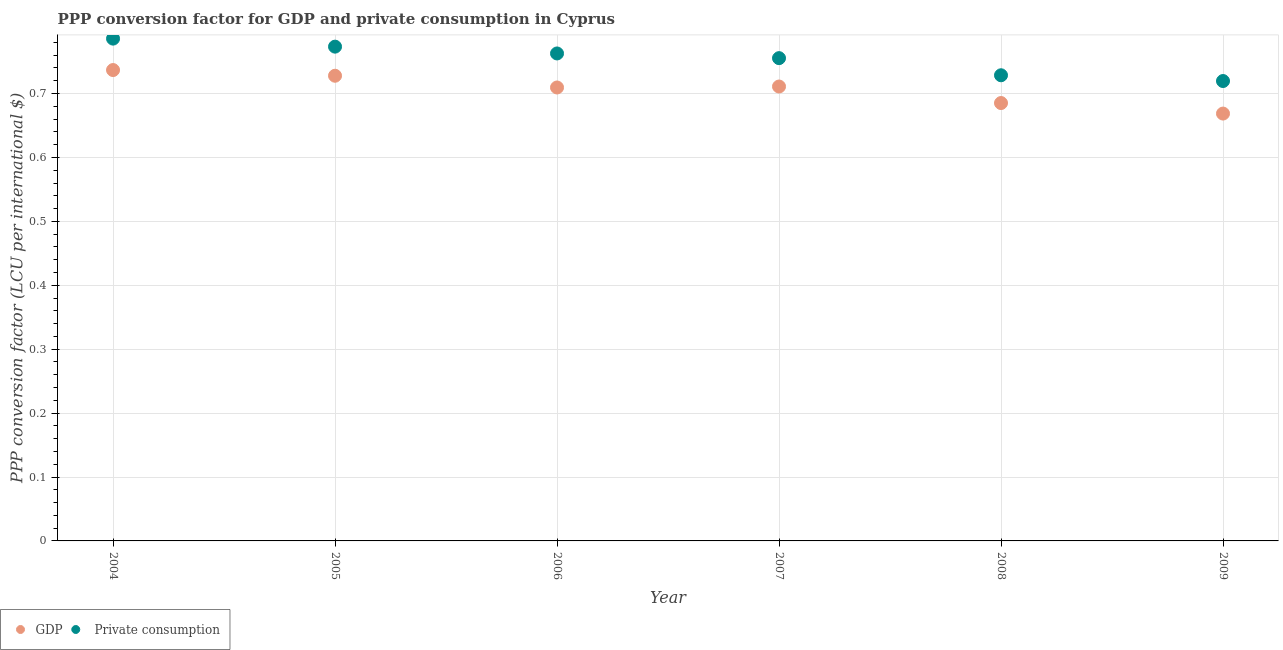How many different coloured dotlines are there?
Your response must be concise. 2. Is the number of dotlines equal to the number of legend labels?
Offer a very short reply. Yes. What is the ppp conversion factor for private consumption in 2007?
Your answer should be very brief. 0.76. Across all years, what is the maximum ppp conversion factor for gdp?
Keep it short and to the point. 0.74. Across all years, what is the minimum ppp conversion factor for private consumption?
Provide a succinct answer. 0.72. In which year was the ppp conversion factor for gdp maximum?
Provide a succinct answer. 2004. In which year was the ppp conversion factor for gdp minimum?
Ensure brevity in your answer.  2009. What is the total ppp conversion factor for gdp in the graph?
Offer a terse response. 4.24. What is the difference between the ppp conversion factor for gdp in 2004 and that in 2006?
Ensure brevity in your answer.  0.03. What is the difference between the ppp conversion factor for private consumption in 2009 and the ppp conversion factor for gdp in 2004?
Keep it short and to the point. -0.02. What is the average ppp conversion factor for gdp per year?
Your answer should be compact. 0.71. In the year 2005, what is the difference between the ppp conversion factor for gdp and ppp conversion factor for private consumption?
Your answer should be very brief. -0.05. In how many years, is the ppp conversion factor for gdp greater than 0.02 LCU?
Provide a short and direct response. 6. What is the ratio of the ppp conversion factor for gdp in 2005 to that in 2006?
Give a very brief answer. 1.03. Is the ppp conversion factor for private consumption in 2005 less than that in 2008?
Keep it short and to the point. No. Is the difference between the ppp conversion factor for private consumption in 2006 and 2007 greater than the difference between the ppp conversion factor for gdp in 2006 and 2007?
Your answer should be very brief. Yes. What is the difference between the highest and the second highest ppp conversion factor for private consumption?
Ensure brevity in your answer.  0.01. What is the difference between the highest and the lowest ppp conversion factor for gdp?
Your answer should be very brief. 0.07. Is the ppp conversion factor for gdp strictly greater than the ppp conversion factor for private consumption over the years?
Your answer should be very brief. No. Is the ppp conversion factor for gdp strictly less than the ppp conversion factor for private consumption over the years?
Provide a succinct answer. Yes. What is the difference between two consecutive major ticks on the Y-axis?
Offer a terse response. 0.1. Does the graph contain any zero values?
Your answer should be very brief. No. How are the legend labels stacked?
Give a very brief answer. Horizontal. What is the title of the graph?
Offer a very short reply. PPP conversion factor for GDP and private consumption in Cyprus. Does "Female entrants" appear as one of the legend labels in the graph?
Ensure brevity in your answer.  No. What is the label or title of the X-axis?
Make the answer very short. Year. What is the label or title of the Y-axis?
Give a very brief answer. PPP conversion factor (LCU per international $). What is the PPP conversion factor (LCU per international $) of GDP in 2004?
Provide a short and direct response. 0.74. What is the PPP conversion factor (LCU per international $) in  Private consumption in 2004?
Provide a succinct answer. 0.79. What is the PPP conversion factor (LCU per international $) of GDP in 2005?
Provide a short and direct response. 0.73. What is the PPP conversion factor (LCU per international $) in  Private consumption in 2005?
Offer a very short reply. 0.77. What is the PPP conversion factor (LCU per international $) of GDP in 2006?
Provide a short and direct response. 0.71. What is the PPP conversion factor (LCU per international $) in  Private consumption in 2006?
Your answer should be very brief. 0.76. What is the PPP conversion factor (LCU per international $) in GDP in 2007?
Provide a succinct answer. 0.71. What is the PPP conversion factor (LCU per international $) of  Private consumption in 2007?
Offer a terse response. 0.76. What is the PPP conversion factor (LCU per international $) of GDP in 2008?
Give a very brief answer. 0.69. What is the PPP conversion factor (LCU per international $) in  Private consumption in 2008?
Your response must be concise. 0.73. What is the PPP conversion factor (LCU per international $) of GDP in 2009?
Make the answer very short. 0.67. What is the PPP conversion factor (LCU per international $) of  Private consumption in 2009?
Give a very brief answer. 0.72. Across all years, what is the maximum PPP conversion factor (LCU per international $) of GDP?
Make the answer very short. 0.74. Across all years, what is the maximum PPP conversion factor (LCU per international $) of  Private consumption?
Ensure brevity in your answer.  0.79. Across all years, what is the minimum PPP conversion factor (LCU per international $) of GDP?
Your response must be concise. 0.67. Across all years, what is the minimum PPP conversion factor (LCU per international $) in  Private consumption?
Your response must be concise. 0.72. What is the total PPP conversion factor (LCU per international $) of GDP in the graph?
Keep it short and to the point. 4.24. What is the total PPP conversion factor (LCU per international $) of  Private consumption in the graph?
Offer a very short reply. 4.53. What is the difference between the PPP conversion factor (LCU per international $) of GDP in 2004 and that in 2005?
Make the answer very short. 0.01. What is the difference between the PPP conversion factor (LCU per international $) in  Private consumption in 2004 and that in 2005?
Keep it short and to the point. 0.01. What is the difference between the PPP conversion factor (LCU per international $) of GDP in 2004 and that in 2006?
Your response must be concise. 0.03. What is the difference between the PPP conversion factor (LCU per international $) in  Private consumption in 2004 and that in 2006?
Give a very brief answer. 0.02. What is the difference between the PPP conversion factor (LCU per international $) in GDP in 2004 and that in 2007?
Ensure brevity in your answer.  0.03. What is the difference between the PPP conversion factor (LCU per international $) in  Private consumption in 2004 and that in 2007?
Ensure brevity in your answer.  0.03. What is the difference between the PPP conversion factor (LCU per international $) in GDP in 2004 and that in 2008?
Your answer should be compact. 0.05. What is the difference between the PPP conversion factor (LCU per international $) of  Private consumption in 2004 and that in 2008?
Offer a terse response. 0.06. What is the difference between the PPP conversion factor (LCU per international $) of GDP in 2004 and that in 2009?
Keep it short and to the point. 0.07. What is the difference between the PPP conversion factor (LCU per international $) of  Private consumption in 2004 and that in 2009?
Provide a short and direct response. 0.07. What is the difference between the PPP conversion factor (LCU per international $) of GDP in 2005 and that in 2006?
Offer a terse response. 0.02. What is the difference between the PPP conversion factor (LCU per international $) of  Private consumption in 2005 and that in 2006?
Your response must be concise. 0.01. What is the difference between the PPP conversion factor (LCU per international $) in GDP in 2005 and that in 2007?
Ensure brevity in your answer.  0.02. What is the difference between the PPP conversion factor (LCU per international $) in  Private consumption in 2005 and that in 2007?
Give a very brief answer. 0.02. What is the difference between the PPP conversion factor (LCU per international $) in GDP in 2005 and that in 2008?
Your answer should be compact. 0.04. What is the difference between the PPP conversion factor (LCU per international $) of  Private consumption in 2005 and that in 2008?
Ensure brevity in your answer.  0.04. What is the difference between the PPP conversion factor (LCU per international $) of GDP in 2005 and that in 2009?
Give a very brief answer. 0.06. What is the difference between the PPP conversion factor (LCU per international $) of  Private consumption in 2005 and that in 2009?
Give a very brief answer. 0.05. What is the difference between the PPP conversion factor (LCU per international $) of GDP in 2006 and that in 2007?
Provide a short and direct response. -0. What is the difference between the PPP conversion factor (LCU per international $) in  Private consumption in 2006 and that in 2007?
Give a very brief answer. 0.01. What is the difference between the PPP conversion factor (LCU per international $) of GDP in 2006 and that in 2008?
Offer a terse response. 0.02. What is the difference between the PPP conversion factor (LCU per international $) in  Private consumption in 2006 and that in 2008?
Provide a succinct answer. 0.03. What is the difference between the PPP conversion factor (LCU per international $) in GDP in 2006 and that in 2009?
Your answer should be very brief. 0.04. What is the difference between the PPP conversion factor (LCU per international $) of  Private consumption in 2006 and that in 2009?
Provide a succinct answer. 0.04. What is the difference between the PPP conversion factor (LCU per international $) of GDP in 2007 and that in 2008?
Offer a terse response. 0.03. What is the difference between the PPP conversion factor (LCU per international $) in  Private consumption in 2007 and that in 2008?
Provide a succinct answer. 0.03. What is the difference between the PPP conversion factor (LCU per international $) of GDP in 2007 and that in 2009?
Provide a succinct answer. 0.04. What is the difference between the PPP conversion factor (LCU per international $) of  Private consumption in 2007 and that in 2009?
Provide a short and direct response. 0.04. What is the difference between the PPP conversion factor (LCU per international $) in GDP in 2008 and that in 2009?
Offer a very short reply. 0.02. What is the difference between the PPP conversion factor (LCU per international $) in  Private consumption in 2008 and that in 2009?
Your response must be concise. 0.01. What is the difference between the PPP conversion factor (LCU per international $) in GDP in 2004 and the PPP conversion factor (LCU per international $) in  Private consumption in 2005?
Offer a very short reply. -0.04. What is the difference between the PPP conversion factor (LCU per international $) of GDP in 2004 and the PPP conversion factor (LCU per international $) of  Private consumption in 2006?
Your answer should be very brief. -0.03. What is the difference between the PPP conversion factor (LCU per international $) in GDP in 2004 and the PPP conversion factor (LCU per international $) in  Private consumption in 2007?
Offer a terse response. -0.02. What is the difference between the PPP conversion factor (LCU per international $) of GDP in 2004 and the PPP conversion factor (LCU per international $) of  Private consumption in 2008?
Your answer should be very brief. 0.01. What is the difference between the PPP conversion factor (LCU per international $) of GDP in 2004 and the PPP conversion factor (LCU per international $) of  Private consumption in 2009?
Provide a short and direct response. 0.02. What is the difference between the PPP conversion factor (LCU per international $) of GDP in 2005 and the PPP conversion factor (LCU per international $) of  Private consumption in 2006?
Your answer should be compact. -0.03. What is the difference between the PPP conversion factor (LCU per international $) of GDP in 2005 and the PPP conversion factor (LCU per international $) of  Private consumption in 2007?
Your answer should be compact. -0.03. What is the difference between the PPP conversion factor (LCU per international $) in GDP in 2005 and the PPP conversion factor (LCU per international $) in  Private consumption in 2008?
Keep it short and to the point. -0. What is the difference between the PPP conversion factor (LCU per international $) of GDP in 2005 and the PPP conversion factor (LCU per international $) of  Private consumption in 2009?
Your response must be concise. 0.01. What is the difference between the PPP conversion factor (LCU per international $) of GDP in 2006 and the PPP conversion factor (LCU per international $) of  Private consumption in 2007?
Offer a terse response. -0.05. What is the difference between the PPP conversion factor (LCU per international $) of GDP in 2006 and the PPP conversion factor (LCU per international $) of  Private consumption in 2008?
Make the answer very short. -0.02. What is the difference between the PPP conversion factor (LCU per international $) in GDP in 2006 and the PPP conversion factor (LCU per international $) in  Private consumption in 2009?
Offer a terse response. -0.01. What is the difference between the PPP conversion factor (LCU per international $) in GDP in 2007 and the PPP conversion factor (LCU per international $) in  Private consumption in 2008?
Provide a short and direct response. -0.02. What is the difference between the PPP conversion factor (LCU per international $) in GDP in 2007 and the PPP conversion factor (LCU per international $) in  Private consumption in 2009?
Make the answer very short. -0.01. What is the difference between the PPP conversion factor (LCU per international $) in GDP in 2008 and the PPP conversion factor (LCU per international $) in  Private consumption in 2009?
Make the answer very short. -0.03. What is the average PPP conversion factor (LCU per international $) in GDP per year?
Keep it short and to the point. 0.71. What is the average PPP conversion factor (LCU per international $) of  Private consumption per year?
Offer a very short reply. 0.75. In the year 2004, what is the difference between the PPP conversion factor (LCU per international $) in GDP and PPP conversion factor (LCU per international $) in  Private consumption?
Give a very brief answer. -0.05. In the year 2005, what is the difference between the PPP conversion factor (LCU per international $) of GDP and PPP conversion factor (LCU per international $) of  Private consumption?
Offer a terse response. -0.05. In the year 2006, what is the difference between the PPP conversion factor (LCU per international $) in GDP and PPP conversion factor (LCU per international $) in  Private consumption?
Make the answer very short. -0.05. In the year 2007, what is the difference between the PPP conversion factor (LCU per international $) of GDP and PPP conversion factor (LCU per international $) of  Private consumption?
Your response must be concise. -0.04. In the year 2008, what is the difference between the PPP conversion factor (LCU per international $) of GDP and PPP conversion factor (LCU per international $) of  Private consumption?
Offer a terse response. -0.04. In the year 2009, what is the difference between the PPP conversion factor (LCU per international $) in GDP and PPP conversion factor (LCU per international $) in  Private consumption?
Your response must be concise. -0.05. What is the ratio of the PPP conversion factor (LCU per international $) of GDP in 2004 to that in 2005?
Provide a short and direct response. 1.01. What is the ratio of the PPP conversion factor (LCU per international $) in  Private consumption in 2004 to that in 2005?
Offer a very short reply. 1.02. What is the ratio of the PPP conversion factor (LCU per international $) in  Private consumption in 2004 to that in 2006?
Provide a succinct answer. 1.03. What is the ratio of the PPP conversion factor (LCU per international $) in GDP in 2004 to that in 2007?
Your answer should be very brief. 1.04. What is the ratio of the PPP conversion factor (LCU per international $) of  Private consumption in 2004 to that in 2007?
Provide a short and direct response. 1.04. What is the ratio of the PPP conversion factor (LCU per international $) in GDP in 2004 to that in 2008?
Your response must be concise. 1.08. What is the ratio of the PPP conversion factor (LCU per international $) in  Private consumption in 2004 to that in 2008?
Provide a short and direct response. 1.08. What is the ratio of the PPP conversion factor (LCU per international $) of GDP in 2004 to that in 2009?
Your answer should be very brief. 1.1. What is the ratio of the PPP conversion factor (LCU per international $) of  Private consumption in 2004 to that in 2009?
Ensure brevity in your answer.  1.09. What is the ratio of the PPP conversion factor (LCU per international $) in GDP in 2005 to that in 2006?
Offer a terse response. 1.03. What is the ratio of the PPP conversion factor (LCU per international $) in  Private consumption in 2005 to that in 2006?
Provide a succinct answer. 1.01. What is the ratio of the PPP conversion factor (LCU per international $) of GDP in 2005 to that in 2007?
Give a very brief answer. 1.02. What is the ratio of the PPP conversion factor (LCU per international $) in  Private consumption in 2005 to that in 2007?
Ensure brevity in your answer.  1.02. What is the ratio of the PPP conversion factor (LCU per international $) of GDP in 2005 to that in 2008?
Your answer should be compact. 1.06. What is the ratio of the PPP conversion factor (LCU per international $) of  Private consumption in 2005 to that in 2008?
Offer a terse response. 1.06. What is the ratio of the PPP conversion factor (LCU per international $) of GDP in 2005 to that in 2009?
Offer a terse response. 1.09. What is the ratio of the PPP conversion factor (LCU per international $) in  Private consumption in 2005 to that in 2009?
Your response must be concise. 1.07. What is the ratio of the PPP conversion factor (LCU per international $) of GDP in 2006 to that in 2007?
Provide a succinct answer. 1. What is the ratio of the PPP conversion factor (LCU per international $) of  Private consumption in 2006 to that in 2007?
Provide a short and direct response. 1.01. What is the ratio of the PPP conversion factor (LCU per international $) of GDP in 2006 to that in 2008?
Offer a terse response. 1.04. What is the ratio of the PPP conversion factor (LCU per international $) in  Private consumption in 2006 to that in 2008?
Provide a short and direct response. 1.05. What is the ratio of the PPP conversion factor (LCU per international $) of GDP in 2006 to that in 2009?
Give a very brief answer. 1.06. What is the ratio of the PPP conversion factor (LCU per international $) in  Private consumption in 2006 to that in 2009?
Offer a very short reply. 1.06. What is the ratio of the PPP conversion factor (LCU per international $) in GDP in 2007 to that in 2008?
Provide a short and direct response. 1.04. What is the ratio of the PPP conversion factor (LCU per international $) of  Private consumption in 2007 to that in 2008?
Give a very brief answer. 1.04. What is the ratio of the PPP conversion factor (LCU per international $) of GDP in 2007 to that in 2009?
Offer a very short reply. 1.06. What is the ratio of the PPP conversion factor (LCU per international $) in  Private consumption in 2007 to that in 2009?
Your answer should be compact. 1.05. What is the ratio of the PPP conversion factor (LCU per international $) in GDP in 2008 to that in 2009?
Make the answer very short. 1.02. What is the ratio of the PPP conversion factor (LCU per international $) in  Private consumption in 2008 to that in 2009?
Make the answer very short. 1.01. What is the difference between the highest and the second highest PPP conversion factor (LCU per international $) in GDP?
Your response must be concise. 0.01. What is the difference between the highest and the second highest PPP conversion factor (LCU per international $) of  Private consumption?
Make the answer very short. 0.01. What is the difference between the highest and the lowest PPP conversion factor (LCU per international $) of GDP?
Offer a terse response. 0.07. What is the difference between the highest and the lowest PPP conversion factor (LCU per international $) in  Private consumption?
Your response must be concise. 0.07. 